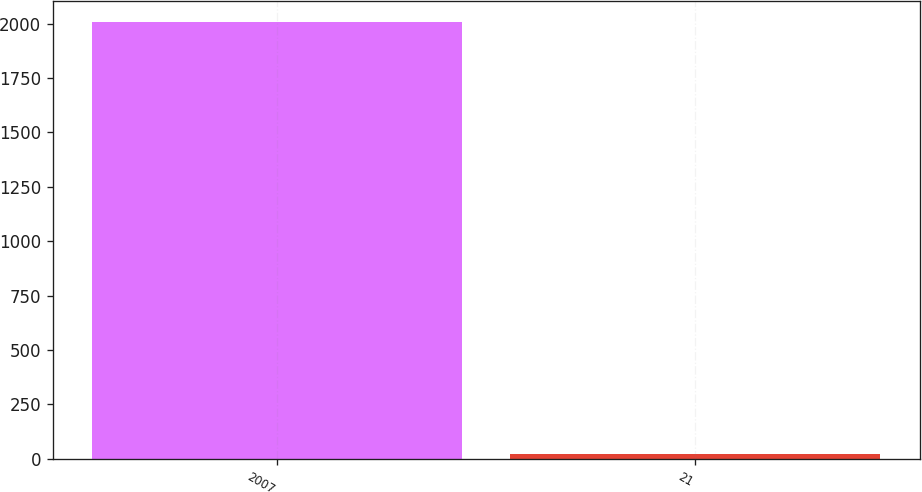Convert chart to OTSL. <chart><loc_0><loc_0><loc_500><loc_500><bar_chart><fcel>2007<fcel>21<nl><fcel>2006<fcel>21<nl></chart> 